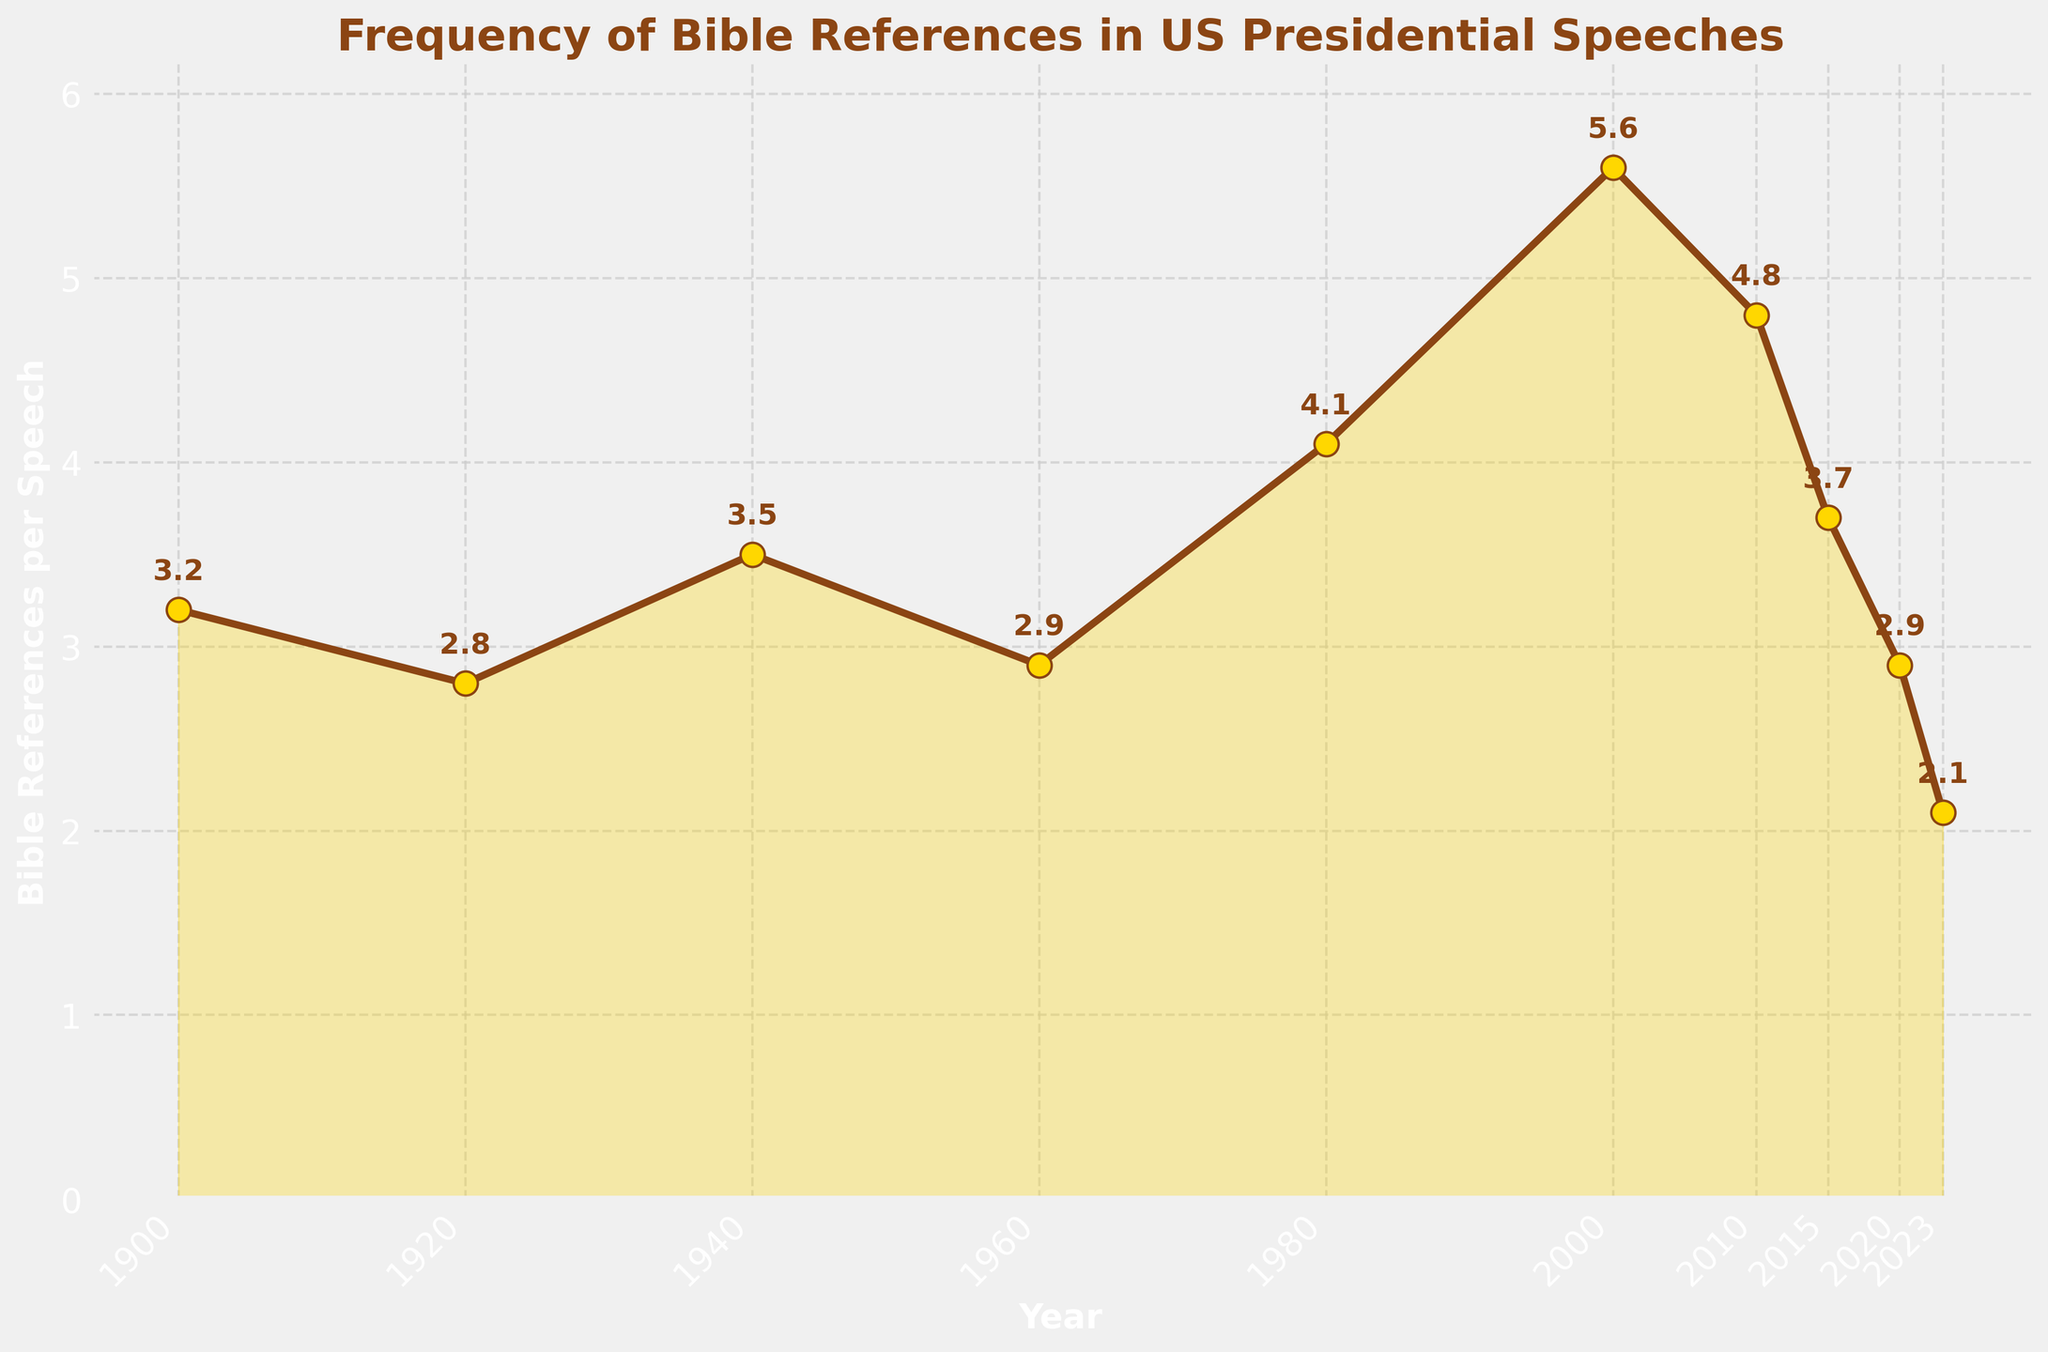What is the first year when Bible references per speech reached 4? To answer this question, locate the year on the x-axis when the y-axis value (Bible references per speech) first equals or exceeds 4. By scanning the plot, we find that the first time this happens is in 1980.
Answer: 1980 How much did the Bible references per speech increase from 2000 to 2010? Identify the values for the years 2000 and 2010 from the plot. For 2000, the value is 5.6, and for 2010, it is 4.8. Calculate the difference: 5.6 - 4.8 = 0.8.
Answer: 0.8 What is the trend of Bible references per speech from 2000 to 2023? Observing the slope of the line from 2000 to 2023, note that it generally decreases. It starts from 5.6 in 2000 and ends at 2.1 in 2023, indicating a downward trend.
Answer: Downward Which year had the maximum number of Bible references per speech and what was the value? Scan the y-values to find the maximum, which is 5.6 in 2000. This corresponds to the peak on the plot.
Answer: 2000, 5.6 Between which two consecutive years was the largest increase in Bible references per speech observed? Examine the plot to identify the largest positive difference between consecutive points. The largest increase is between 1960 (2.9) and 1980 (4.1), which is 4.1 - 2.9 = 1.2.
Answer: 1960 to 1980 How many years had Bible references per speech of 3 or more? Count the points on the plot with y-values of 3 or higher. The years are 1900, 1920, 1940, 1960, 1980, 2000, 2010, and 2015. This totals to 8 years.
Answer: 8 What is the average Bible references per speech from 1900 to 2023? Sum the y-values: 3.2 + 2.8 + 3.5 + 2.9 + 4.1 + 5.6 + 4.8 + 3.7 + 2.9 + 2.1 = 35.6. There are 10 data points: 35.6 / 10 = 3.56.
Answer: 3.56 How did the Bible references per speech change from 2015 to 2023? Reference the values for 2015 (3.7) and 2023 (2.1). The change is calculated as 2.1 - 3.7, resulting in a decrease of 1.6.
Answer: Decrease by 1.6 Is the value for 1900 greater than or equal to the value for 2023? By looking at the plot, it is evident that 1900 had 3.2 Bible references per speech, and 2023 had 2.1. Since 3.2 > 2.1, the value for 1900 is greater than the value for 2023.
Answer: Yes Which years had a lower number of Bible references per speech compared to 1980? Check the plot for points lower than the 1980 value (4.1). The years 1920 (2.8), 1960 (2.9), 2020 (2.9), and 2023 (2.1) are the data points lower than 4.1.
Answer: 1920, 1960, 2020, 2023 